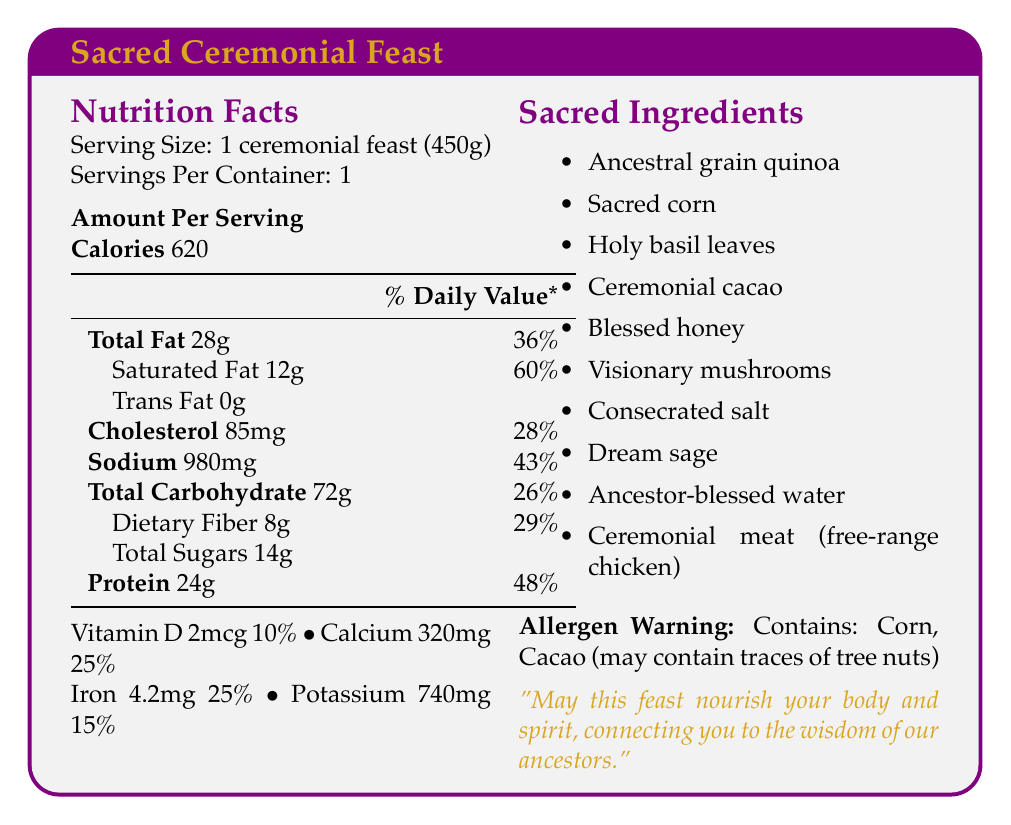what is the serving size for the ceremonial feast? The document specifies that the serving size is 1 ceremonial feast weighing 450 grams.
Answer: 1 ceremonial feast (450g) how many calories are in one serving of the ceremonial feast? The document specifies that each serving contains 620 calories.
Answer: 620 calories what is the percentage of daily value for dietary fiber in the ceremonial feast? The document shows that dietary fiber has a daily value percentage of 29%.
Answer: 29% how much total fat is in the ceremonial feast? The total amount of fat in one serving is listed as 28 grams.
Answer: 28g what are the sacred ingredients used in the ceremonial feast? The document lists the sacred ingredients in the ingredients section on the right column.
Answer: Ancestral grain quinoa, Sacred corn, Holy basil leaves, Ceremonial cacao, Blessed honey, Visionary mushrooms, Consecrated salt, Dream sage, Ancestor-blessed water, Ceremonial meat (free-range chicken) which ingredient in the ceremonial feast symbolizes the connection to ancient wisdom and nourishment? A. Holy basil leaves B. Ancestral grain quinoa C. Blessed honey The document specifies that ancestral grain quinoa symbolizes the connection to ancient wisdom and nourishment.
Answer: B which nutrient has the highest daily value percentage in the ceremonial feast? A. Total Carbohydrate B. Protein C. Saturated Fat Saturated Fat has the highest daily value percentage at 60% according to the document.
Answer: C does the ceremonial feast contain any trans fat? The nutrition facts indicate that the trans fat amount is 0g, implying there is no trans fat.
Answer: No is this ceremonial feast recommended for someone with tree nut allergies? The document states "Allergen Warning: Contains: Corn, Cacao (may contain traces of tree nuts)", indicating it may not be safe for someone with tree nut allergies.
Answer: No what is the main symbolic meaning of the ceremonial feast? The document includes a quote stating, "May this feast nourish your body and spirit, connecting you to the wisdom of our ancestors," which summarizes the primary symbolic meaning.
Answer: The feast aims to nourish both the body and spirit, connecting participants to the wisdom and blessings of their ancestors. what is the total amount of sugars present in the ceremonial feast? The document lists the total sugars amount as 14 grams.
Answer: 14g what is the amount of Vitamin D in the ceremonial feast in terms of daily percentage value? The document states that the amount of Vitamin D is 2mcg, which corresponds to 10% of the daily value.
Answer: 10% which symbolic meaning is associated with visionary mushrooms? A. Protection B. Spiritual awakening C. Expanded consciousness The ingredient description specifies that visionary mushrooms symbolize journeying between worlds and expanded consciousness.
Answer: C how many servings are there per container of the ceremonial feast? The document specifies that there is 1 serving per container.
Answer: 1 what is the meaning associated with blessed honey? According to the sacred ingredients section, blessed honey symbolizes the sweetness of life and ancestral blessings.
Answer: Sweetness of life and ancestral blessings which nutrient helps in spiritual awakening, as per the symbolic meanings of the ingredients? The document states that holy basil leaves symbolize purification and spiritual awakening.
Answer: Holy basil leaves what amount of Sodium is present in the ceremonial feast? The document lists the sodium content as 980mg.
Answer: 980mg what information is missing regarding the daily value percentage of one of the nutrients? The document provides no daily value percentage for trans fat.
Answer: Trans Fat how do the sacred ingredients contribute to the ceremonial feast's symbolism and purpose? Each ingredient is listed with a specific symbolic meaning that contributes to the ritual and spiritual purpose of the feast, emphasizing themes like ancient wisdom, spiritual awakening, and ancestral blessings.
Answer: The sacred ingredients each have unique symbolic meanings, such as purification, divine connection, and enhancing visions, which together aim to provide spiritual nourishment and connect participants to their ancestors. 